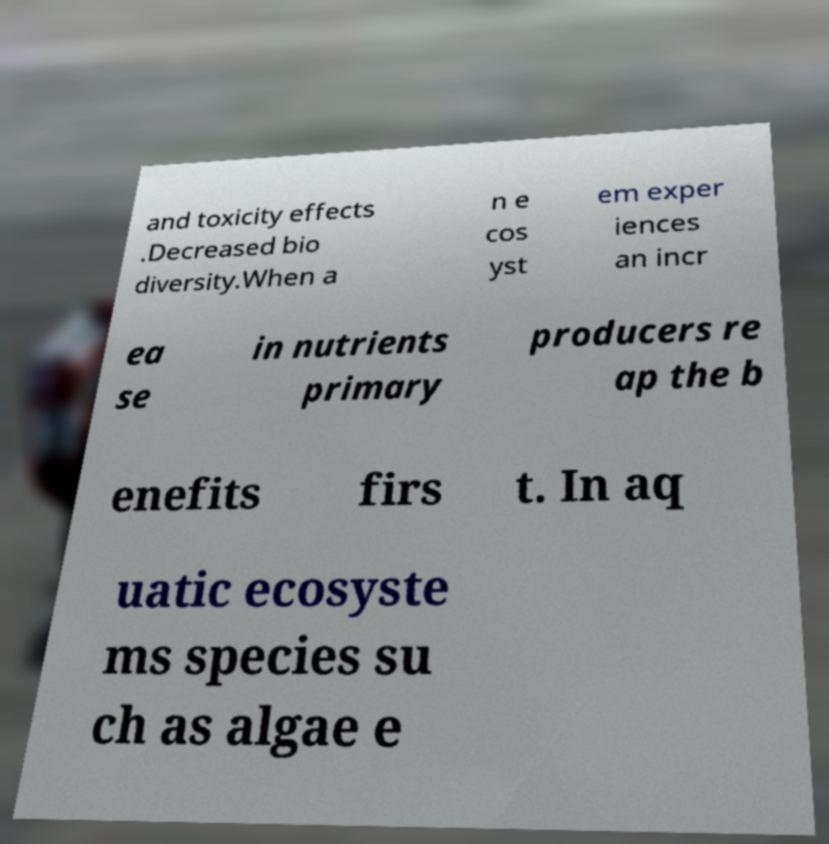What messages or text are displayed in this image? I need them in a readable, typed format. and toxicity effects .Decreased bio diversity.When a n e cos yst em exper iences an incr ea se in nutrients primary producers re ap the b enefits firs t. In aq uatic ecosyste ms species su ch as algae e 